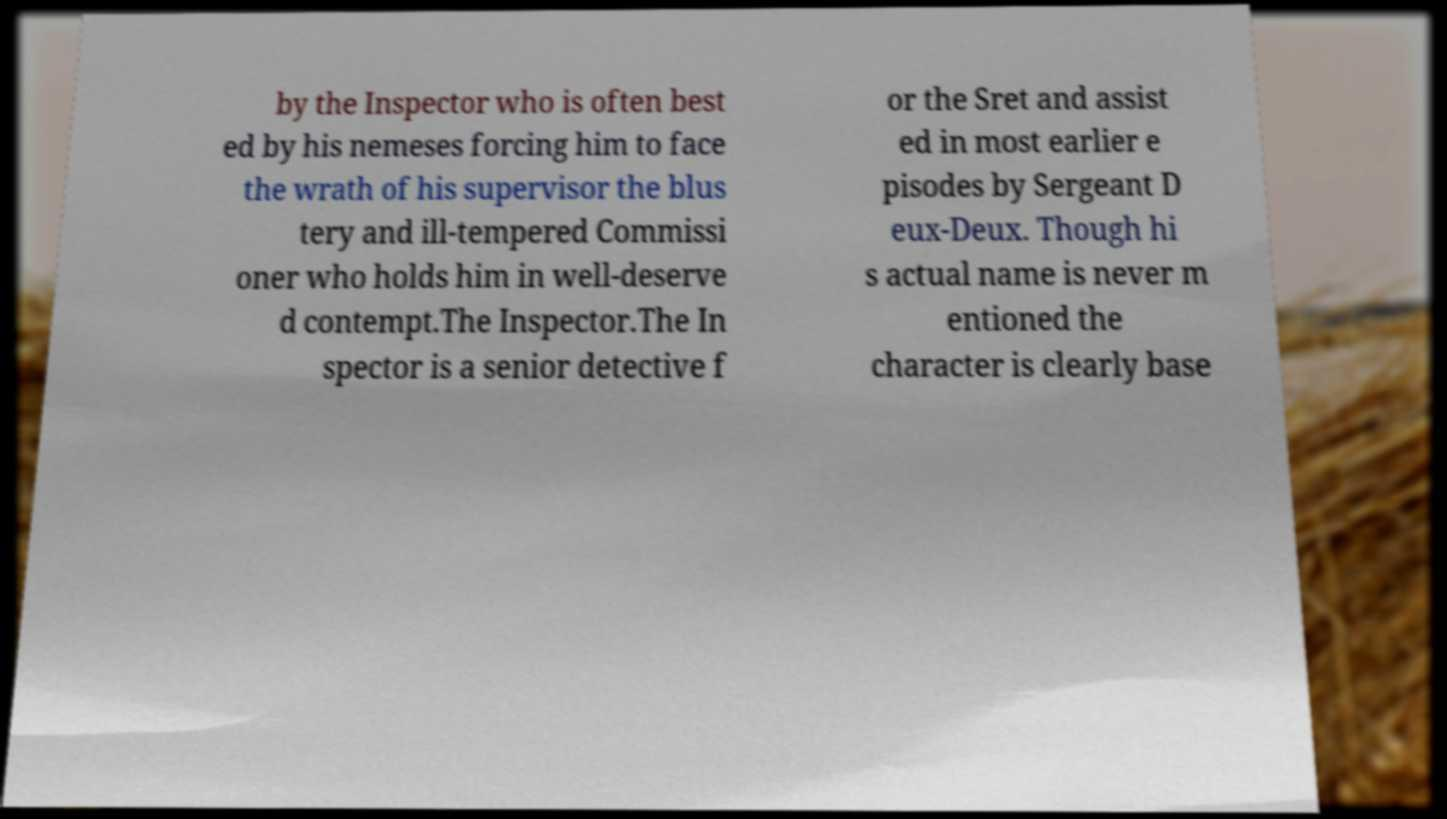Could you extract and type out the text from this image? by the Inspector who is often best ed by his nemeses forcing him to face the wrath of his supervisor the blus tery and ill-tempered Commissi oner who holds him in well-deserve d contempt.The Inspector.The In spector is a senior detective f or the Sret and assist ed in most earlier e pisodes by Sergeant D eux-Deux. Though hi s actual name is never m entioned the character is clearly base 